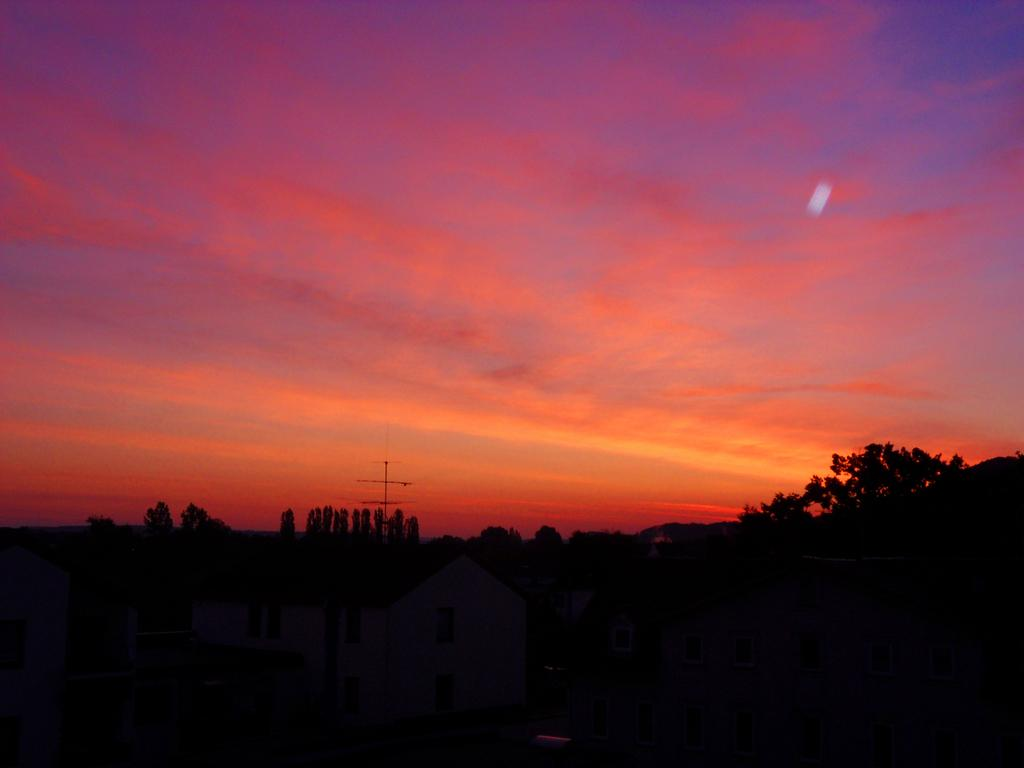What type of natural event is depicted in the image? The image depicts a sunset. What colors can be seen in the sky during the sunset? The sky is a combination of pink and orange colors. What structures are present in the image? There are houses in the image. What type of vegetation surrounds the houses? The houses are surrounded by trees. What type of sidewalk can be seen in the image? There is no sidewalk present in the image; it features a sunset with houses surrounded by trees. 